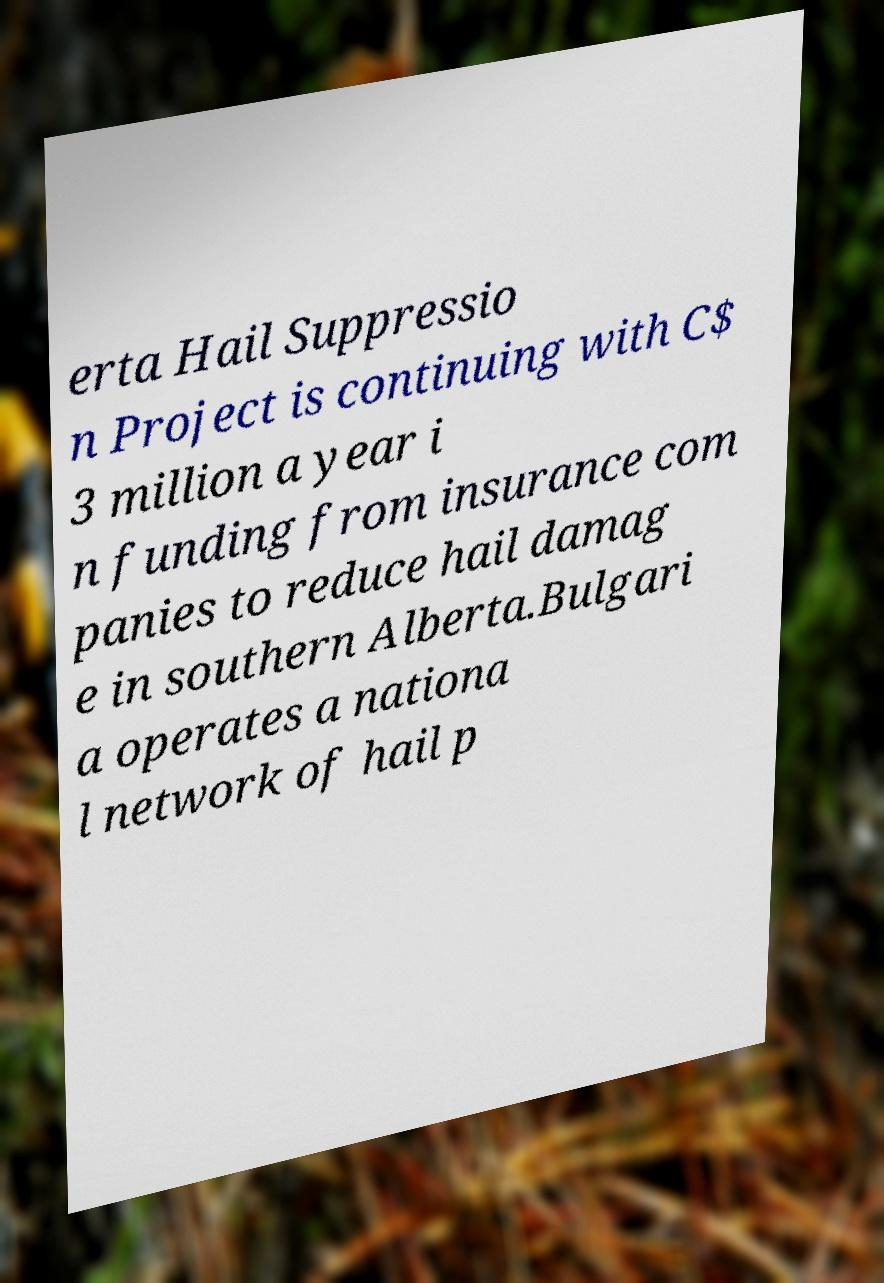Could you extract and type out the text from this image? erta Hail Suppressio n Project is continuing with C$ 3 million a year i n funding from insurance com panies to reduce hail damag e in southern Alberta.Bulgari a operates a nationa l network of hail p 